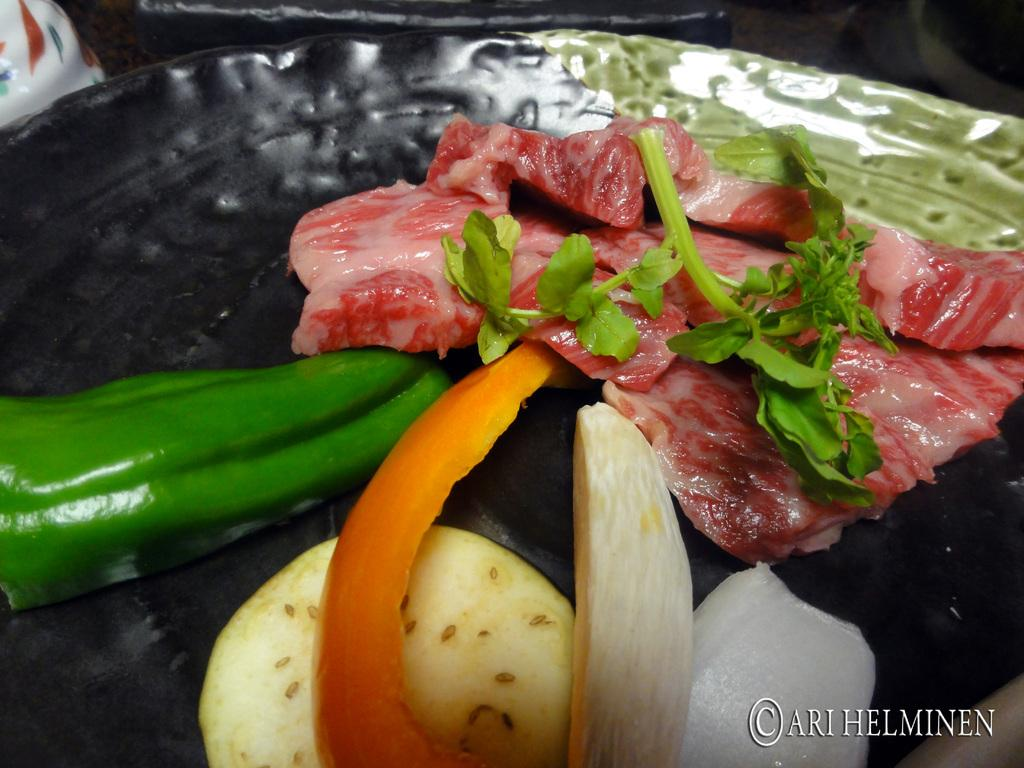What is on the plate that is visible in the image? The plate contains meat and vegetables. What type of object is on the left side of the image? There is a ceramic object on the left side of the image. Where is the plate located in the image? The plate is at the top of the image. What type of paint is used on the country in the image? There is no country or paint present in the image; it features a plate with meat and vegetables and a ceramic object. 